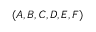<formula> <loc_0><loc_0><loc_500><loc_500>( A , B , C , D , E , F )</formula> 